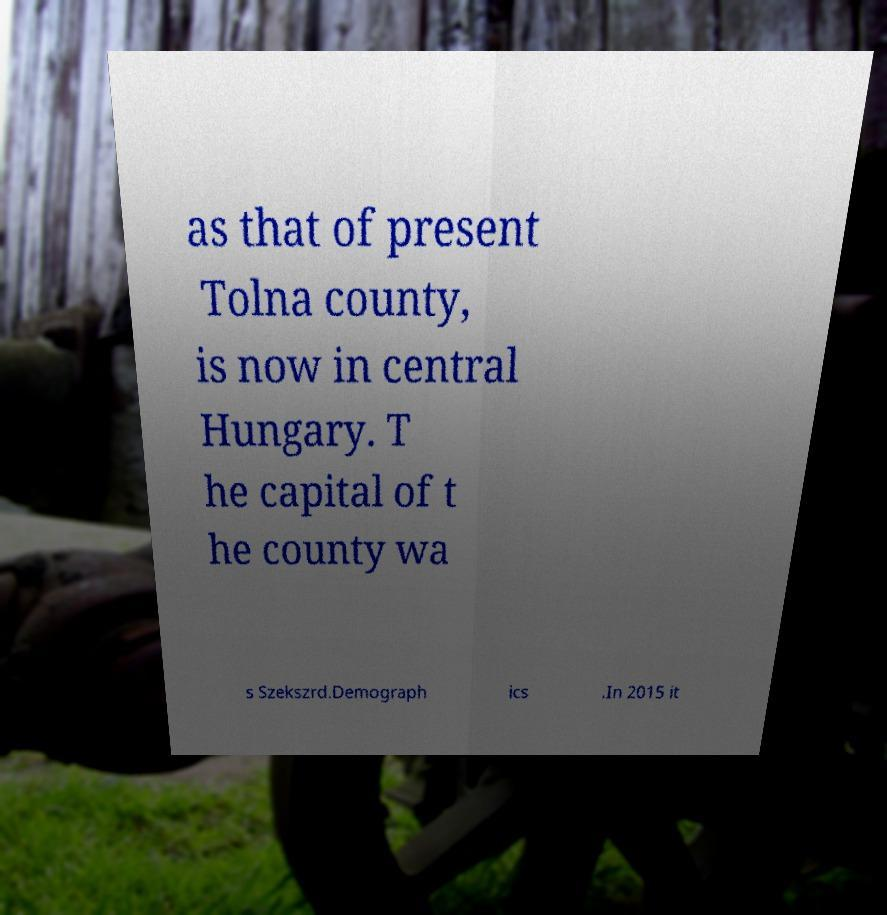Please identify and transcribe the text found in this image. as that of present Tolna county, is now in central Hungary. T he capital of t he county wa s Szekszrd.Demograph ics .In 2015 it 